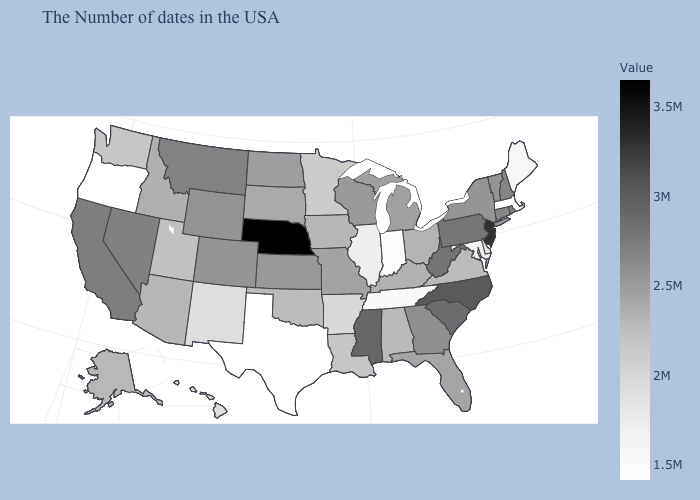Among the states that border South Dakota , which have the lowest value?
Give a very brief answer. Minnesota. Which states have the lowest value in the USA?
Concise answer only. Massachusetts, Texas, Oregon. Does Wyoming have a higher value than Alabama?
Quick response, please. Yes. Does Missouri have a higher value than Montana?
Quick response, please. No. Among the states that border Rhode Island , does Massachusetts have the highest value?
Keep it brief. No. Does Vermont have the highest value in the USA?
Short answer required. No. Among the states that border Ohio , does Michigan have the highest value?
Answer briefly. No. 